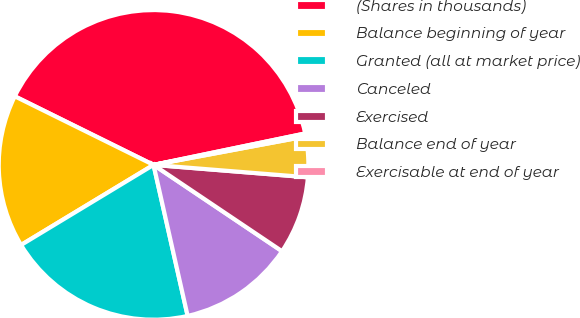<chart> <loc_0><loc_0><loc_500><loc_500><pie_chart><fcel>(Shares in thousands)<fcel>Balance beginning of year<fcel>Granted (all at market price)<fcel>Canceled<fcel>Exercised<fcel>Balance end of year<fcel>Exercisable at end of year<nl><fcel>39.44%<fcel>15.96%<fcel>19.88%<fcel>12.05%<fcel>8.14%<fcel>4.22%<fcel>0.31%<nl></chart> 